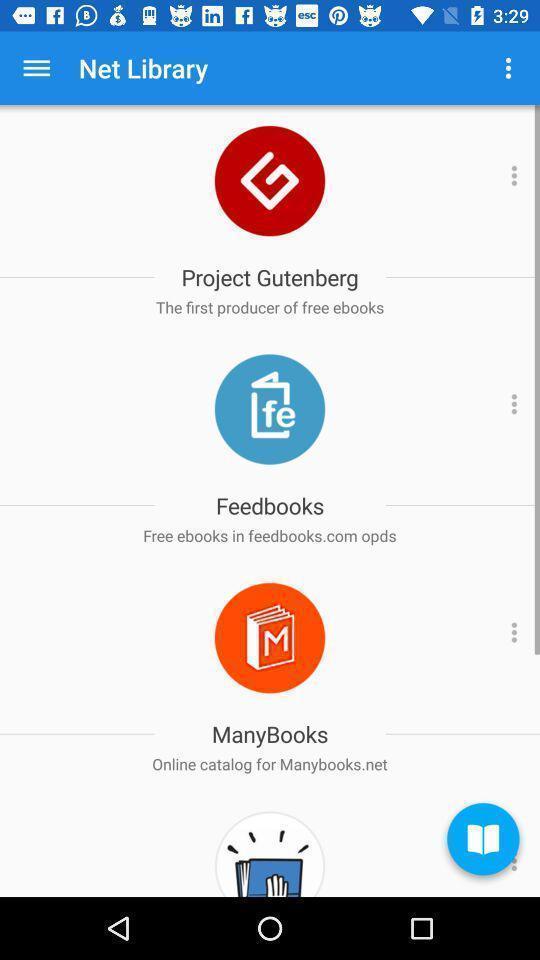Please provide a description for this image. Various tools in a net library app. 